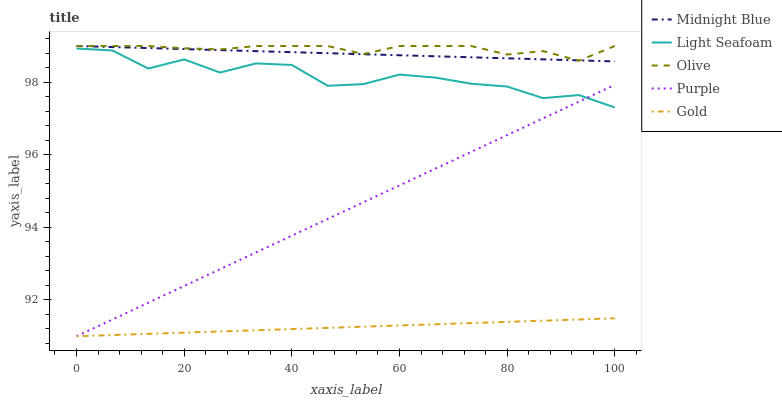Does Gold have the minimum area under the curve?
Answer yes or no. Yes. Does Olive have the maximum area under the curve?
Answer yes or no. Yes. Does Purple have the minimum area under the curve?
Answer yes or no. No. Does Purple have the maximum area under the curve?
Answer yes or no. No. Is Purple the smoothest?
Answer yes or no. Yes. Is Light Seafoam the roughest?
Answer yes or no. Yes. Is Light Seafoam the smoothest?
Answer yes or no. No. Is Purple the roughest?
Answer yes or no. No. Does Purple have the lowest value?
Answer yes or no. Yes. Does Light Seafoam have the lowest value?
Answer yes or no. No. Does Midnight Blue have the highest value?
Answer yes or no. Yes. Does Purple have the highest value?
Answer yes or no. No. Is Purple less than Midnight Blue?
Answer yes or no. Yes. Is Light Seafoam greater than Gold?
Answer yes or no. Yes. Does Purple intersect Gold?
Answer yes or no. Yes. Is Purple less than Gold?
Answer yes or no. No. Is Purple greater than Gold?
Answer yes or no. No. Does Purple intersect Midnight Blue?
Answer yes or no. No. 